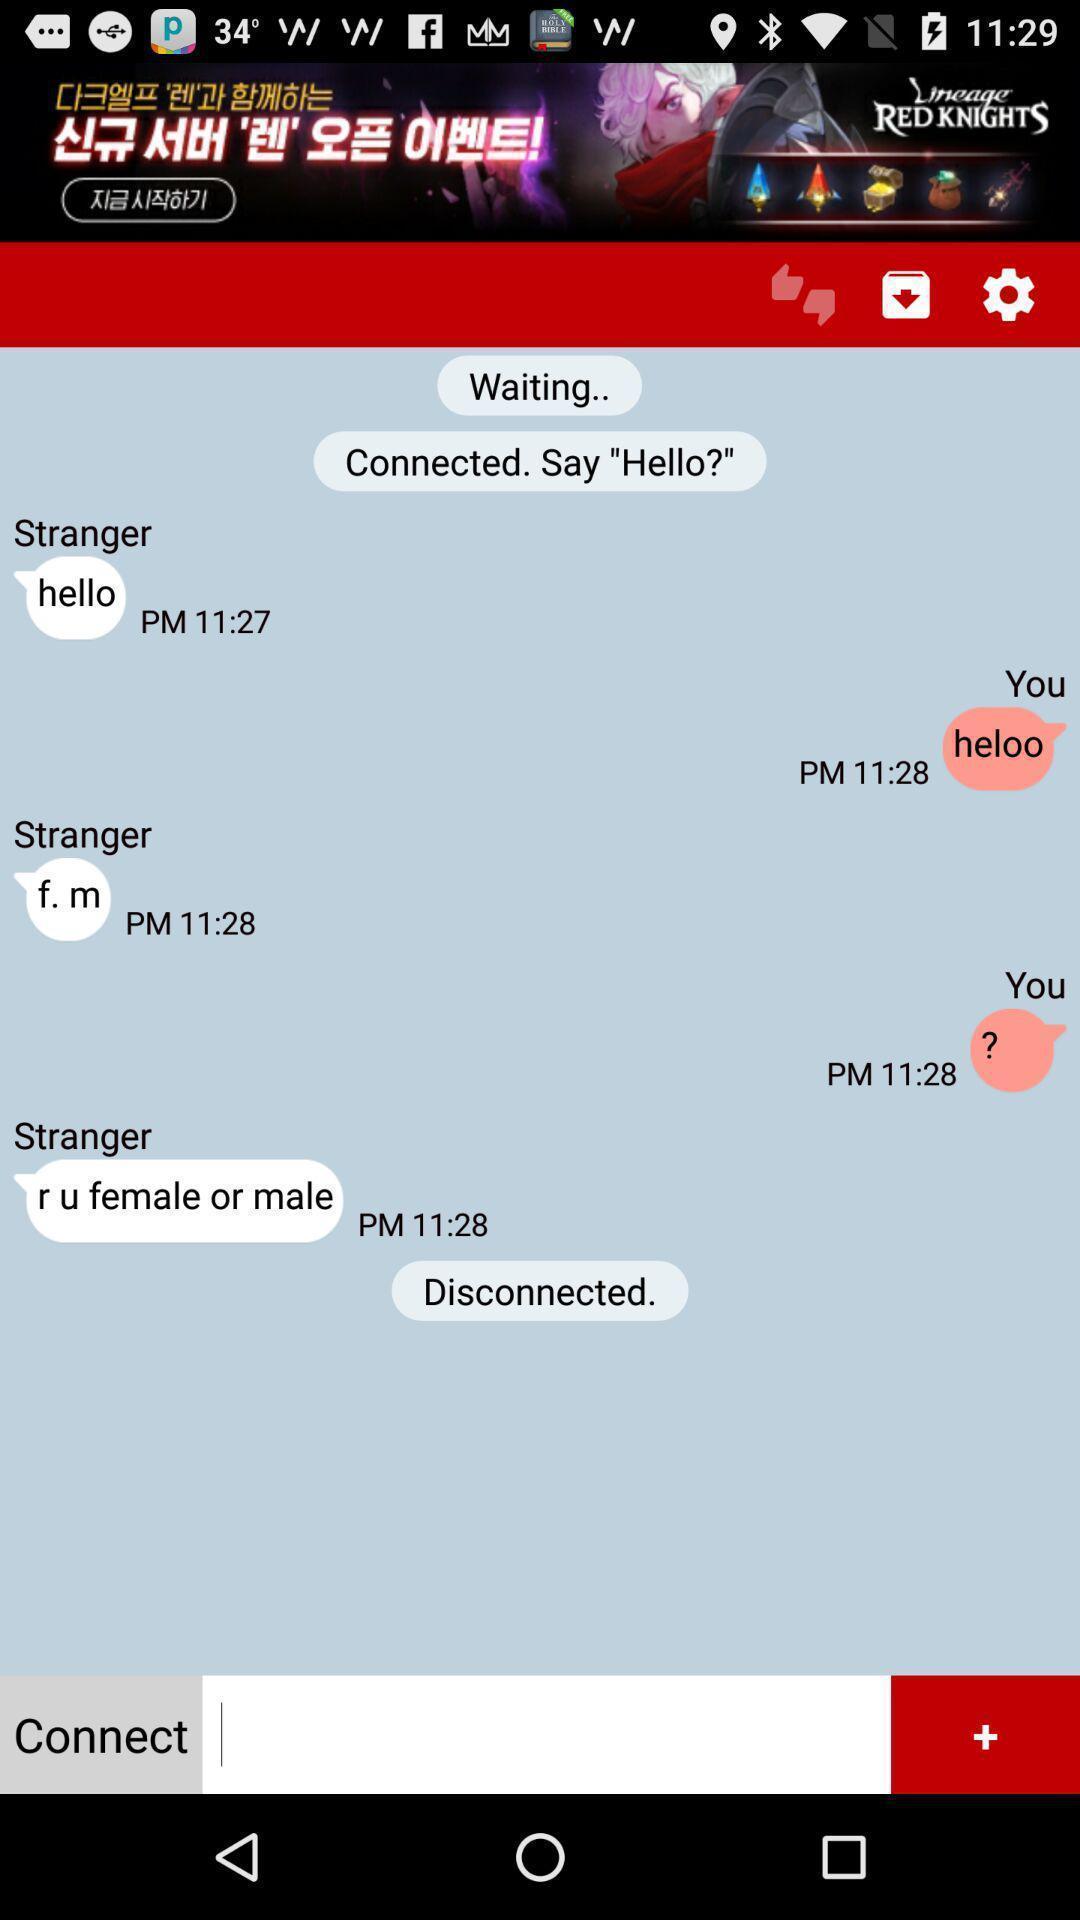Give me a summary of this screen capture. Page displaying the conversation screen. 